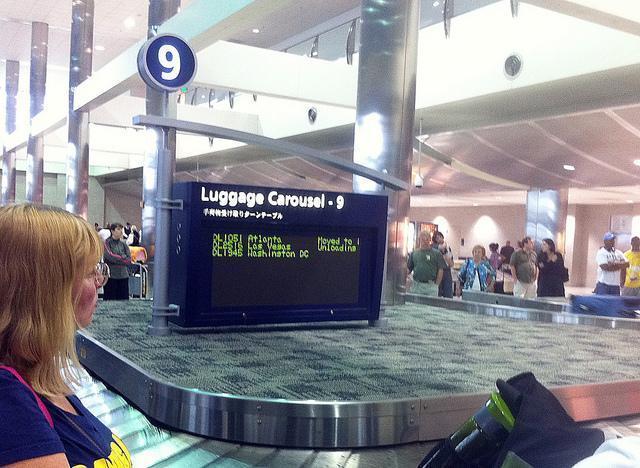How many people are there?
Give a very brief answer. 2. How many skis are level against the snow?
Give a very brief answer. 0. 